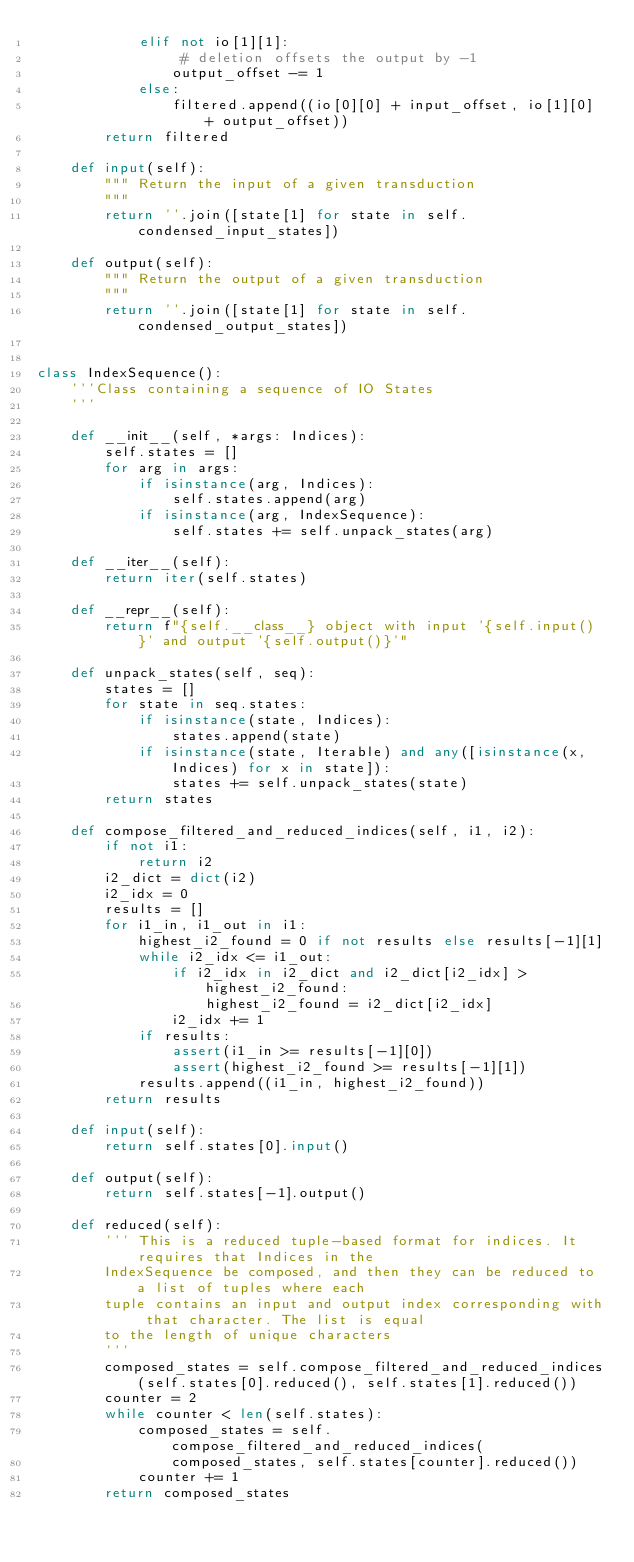Convert code to text. <code><loc_0><loc_0><loc_500><loc_500><_Python_>            elif not io[1][1]:
                 # deletion offsets the output by -1
                output_offset -= 1
            else:
                filtered.append((io[0][0] + input_offset, io[1][0] + output_offset))
        return filtered

    def input(self):
        """ Return the input of a given transduction
        """
        return ''.join([state[1] for state in self.condensed_input_states])

    def output(self):
        """ Return the output of a given transduction
        """
        return ''.join([state[1] for state in self.condensed_output_states])


class IndexSequence():
    '''Class containing a sequence of IO States
    '''

    def __init__(self, *args: Indices):
        self.states = []
        for arg in args:
            if isinstance(arg, Indices):
                self.states.append(arg)
            if isinstance(arg, IndexSequence):
                self.states += self.unpack_states(arg)

    def __iter__(self):
        return iter(self.states)

    def __repr__(self):
        return f"{self.__class__} object with input '{self.input()}' and output '{self.output()}'"

    def unpack_states(self, seq):
        states = []
        for state in seq.states:
            if isinstance(state, Indices):
                states.append(state)
            if isinstance(state, Iterable) and any([isinstance(x, Indices) for x in state]):
                states += self.unpack_states(state)
        return states

    def compose_filtered_and_reduced_indices(self, i1, i2):
        if not i1:
            return i2
        i2_dict = dict(i2)
        i2_idx = 0
        results = []
        for i1_in, i1_out in i1:
            highest_i2_found = 0 if not results else results[-1][1]
            while i2_idx <= i1_out:
                if i2_idx in i2_dict and i2_dict[i2_idx] > highest_i2_found:
                    highest_i2_found = i2_dict[i2_idx]
                i2_idx += 1
            if results:
                assert(i1_in >= results[-1][0])
                assert(highest_i2_found >= results[-1][1])
            results.append((i1_in, highest_i2_found))
        return results

    def input(self):
        return self.states[0].input()

    def output(self):
        return self.states[-1].output()

    def reduced(self):
        ''' This is a reduced tuple-based format for indices. It requires that Indices in the
        IndexSequence be composed, and then they can be reduced to a list of tuples where each
        tuple contains an input and output index corresponding with that character. The list is equal
        to the length of unique characters
        '''
        composed_states = self.compose_filtered_and_reduced_indices(self.states[0].reduced(), self.states[1].reduced())
        counter = 2
        while counter < len(self.states):
            composed_states = self.compose_filtered_and_reduced_indices(
                composed_states, self.states[counter].reduced())
            counter += 1
        return composed_states
</code> 